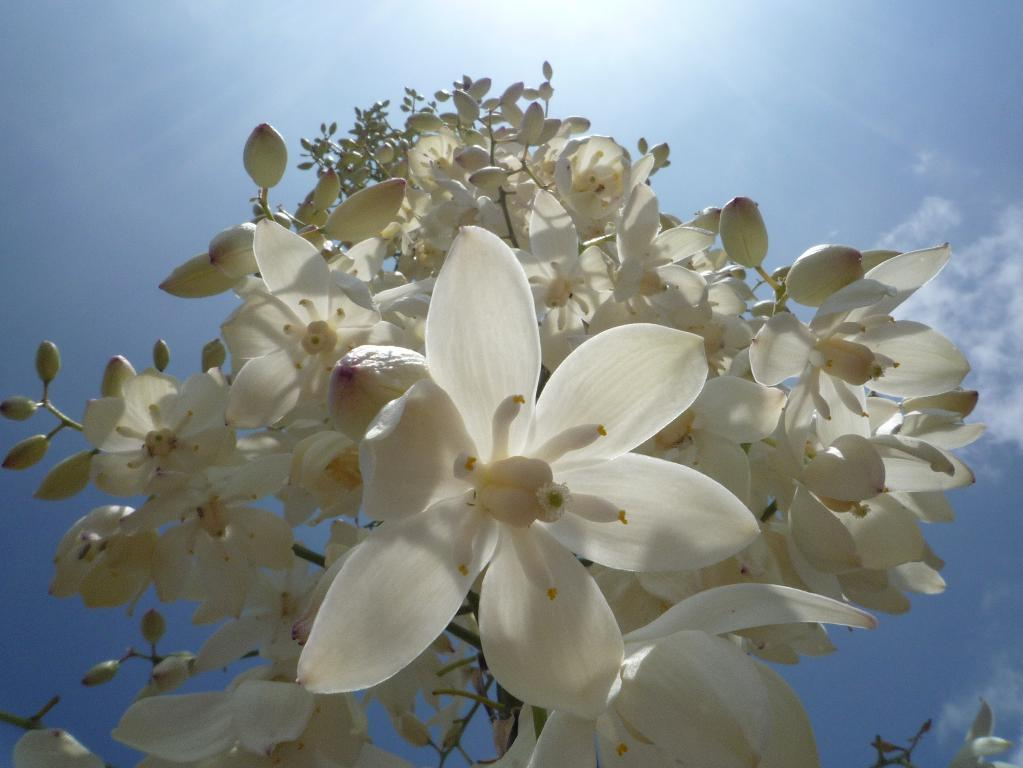What is located in the foreground of the image? There are flowers in the foreground of the image. What can be seen at the top of the image? The sky is visible at the top of the image. What type of joke is being told by the flowers in the image? There is no indication in the image that the flowers are telling a joke, as flowers do not have the ability to speak or tell jokes. 